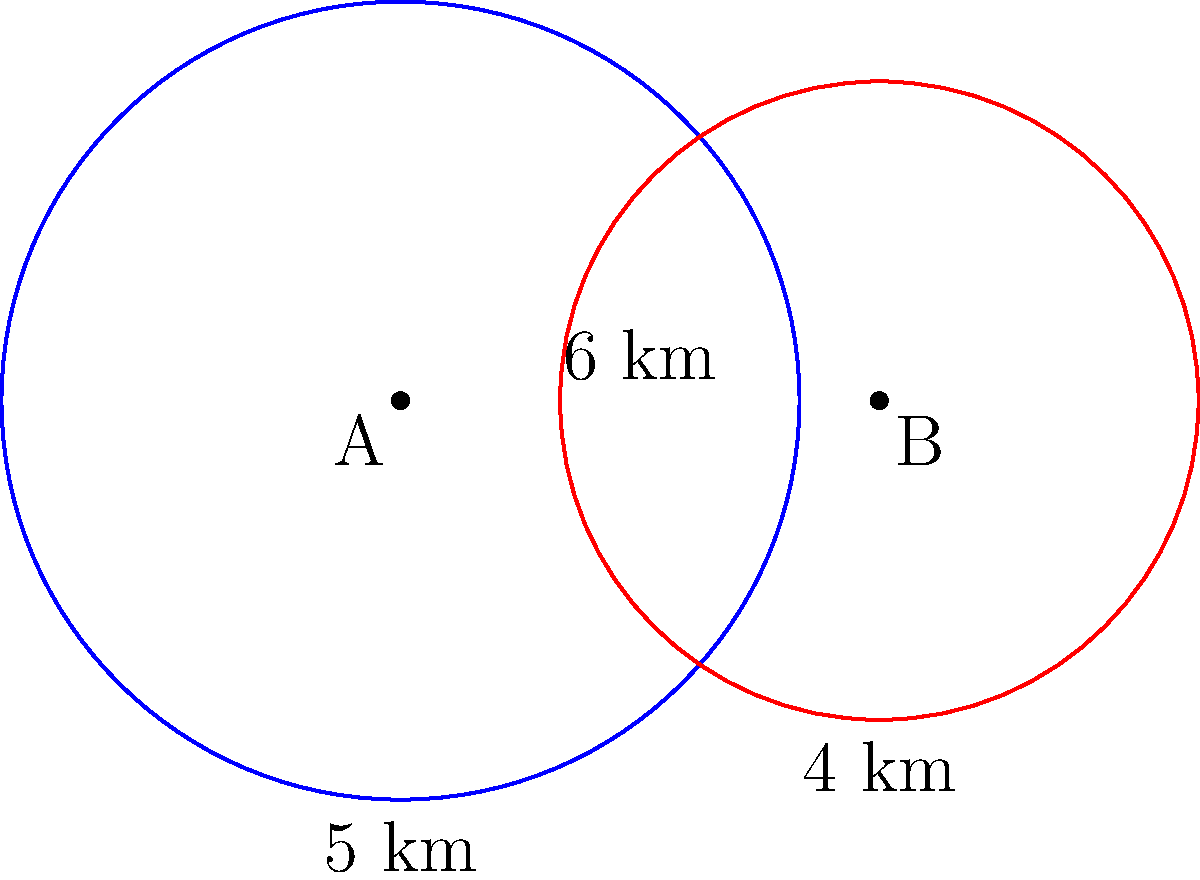Two marketing campaigns, A and B, are represented by circles on a map. Campaign A has a reach radius of 5 km, while Campaign B has a reach radius of 4 km. The centers of these campaigns are 6 km apart. Calculate the area of overlap between these two marketing campaign reach circles to determine the region where both campaigns are effective. To find the area of overlap between two circles, we can use the following steps:

1) First, we need to calculate the distance $d$ between the points of intersection of the two circles. We can use the formula:

   $$d = 2\sqrt{\frac{(a+b+c)(a+b-c)(a-b+c)(-a+b+c)}{16a^2b^2}}$$

   Where $a$ and $b$ are the radii of the circles, and $c$ is the distance between their centers.

2) In this case, $a = 5$ km, $b = 4$ km, and $c = 6$ km. Let's substitute these values:

   $$d = 2\sqrt{\frac{(5+4+6)(5+4-6)(5-4+6)(-5+4+6)}{16(5^2)(4^2)}}$$

3) Simplify:
   
   $$d = 2\sqrt{\frac{(15)(3)(7)(5)}{1600}} = 2\sqrt{\frac{1575}{1600}} = 2\sqrt{0.984375} \approx 1.984$$

4) Now we can calculate the area of overlap using the formula:

   $$A = r_1^2 \arccos(\frac{c^2 + r_1^2 - r_2^2}{2cr_1}) + r_2^2 \arccos(\frac{c^2 + r_2^2 - r_1^2}{2cr_2}) - \frac{1}{2}\sqrt{(-c+r_1+r_2)(c+r_1-r_2)(c-r_1+r_2)(c+r_1+r_2)}$$

5) Substituting our values:

   $$A = 5^2 \arccos(\frac{6^2 + 5^2 - 4^2}{2(6)(5)}) + 4^2 \arccos(\frac{6^2 + 4^2 - 5^2}{2(6)(4)}) - \frac{1}{2}\sqrt{(-6+5+4)(6+5-4)(6-5+4)(6+5+4)}$$

6) Simplify and calculate (using a calculator for the complex trigonometric functions):

   $$A \approx 25(0.5149) + 16(1.0472) - \frac{1}{2}(7.9372)$$
   $$A \approx 12.8725 + 16.7552 - 3.9686$$
   $$A \approx 25.6591$$

Therefore, the area of overlap is approximately 25.66 square kilometers.
Answer: 25.66 km² 